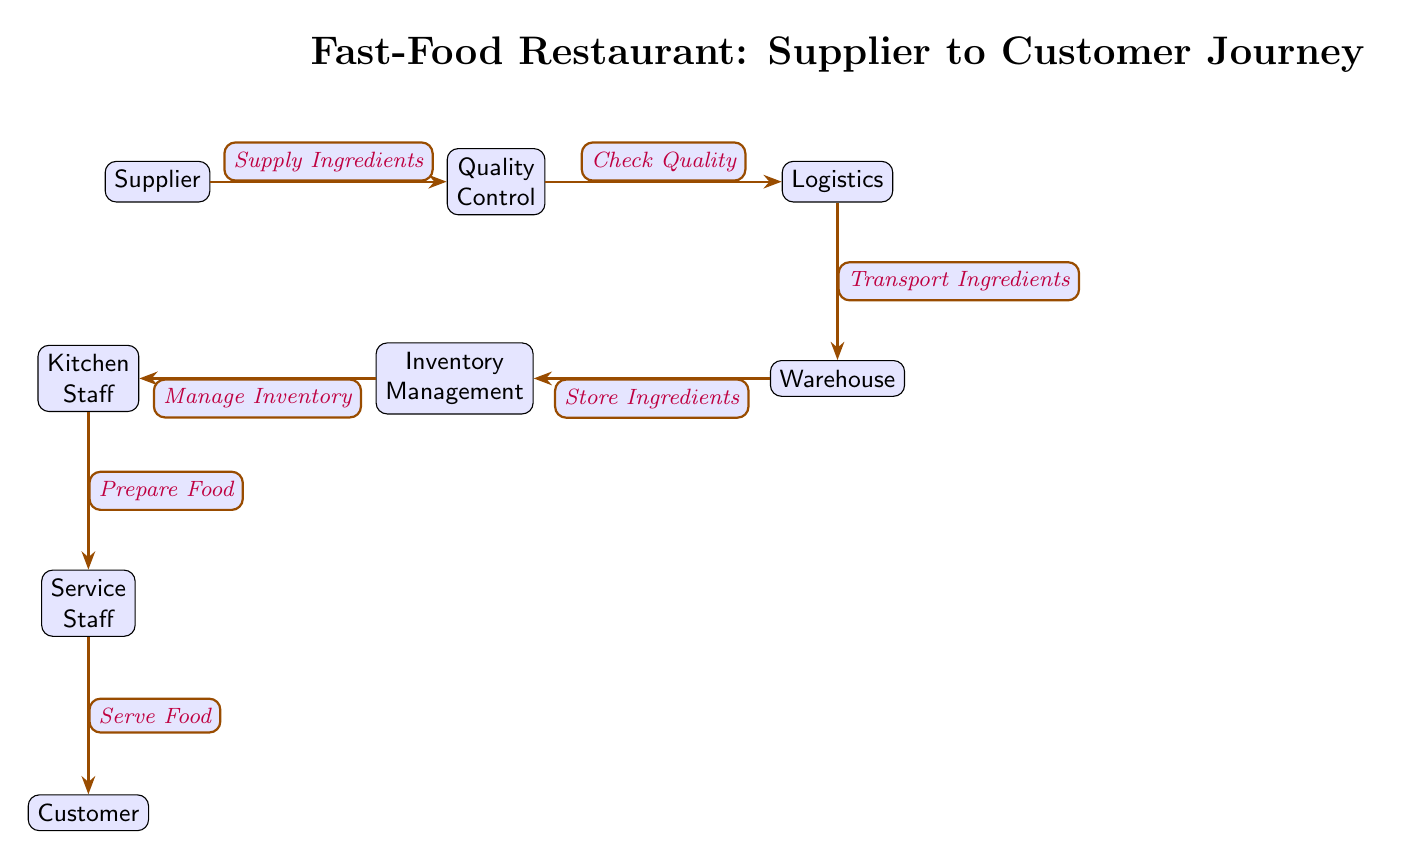What is the first step in the food chain? The first step in the food chain is the "Supplier," which starts the process by providing ingredients.
Answer: Supplier How many nodes are present in the diagram? The diagram contains a total of seven nodes: Supplier, Quality Control, Logistics, Warehouse, Inventory Management, Kitchen Staff, Service Staff, and Customer.
Answer: 7 What is the role of the "Quality Control" node? The role of the "Quality Control" node is to check the quality of the ingredients supplied before they are transported.
Answer: Check Quality Who directly manages the inventory according to the diagram? The "Inventory Management" node is responsible for managing the inventory between the warehouse and the kitchen staff.
Answer: Inventory Management What action occurs between "Logistics" and "Warehouse"? The action that occurs between "Logistics" and "Warehouse" is the transport of ingredients.
Answer: Transport Ingredients How is food prepared in the diagram? Food is prepared in the diagram by the "Kitchen Staff," who manage the kitchen and use the ingredients from inventory.
Answer: Prepare Food What step comes after "Service Staff"? After the "Service Staff," the next step is the "Customer," who receives the food that has been served.
Answer: Customer What is the relationship between "Warehouse" and "Inventory Management"? The relationship between "Warehouse" and "Inventory Management" is that the Warehouse stores ingredients, and Inventory Management oversees those stored ingredients.
Answer: Store Ingredients In what sequence do customers receive their food? Customers receive their food after it has been served by the service staff, following all the preparation steps that come before.
Answer: Serve Food 